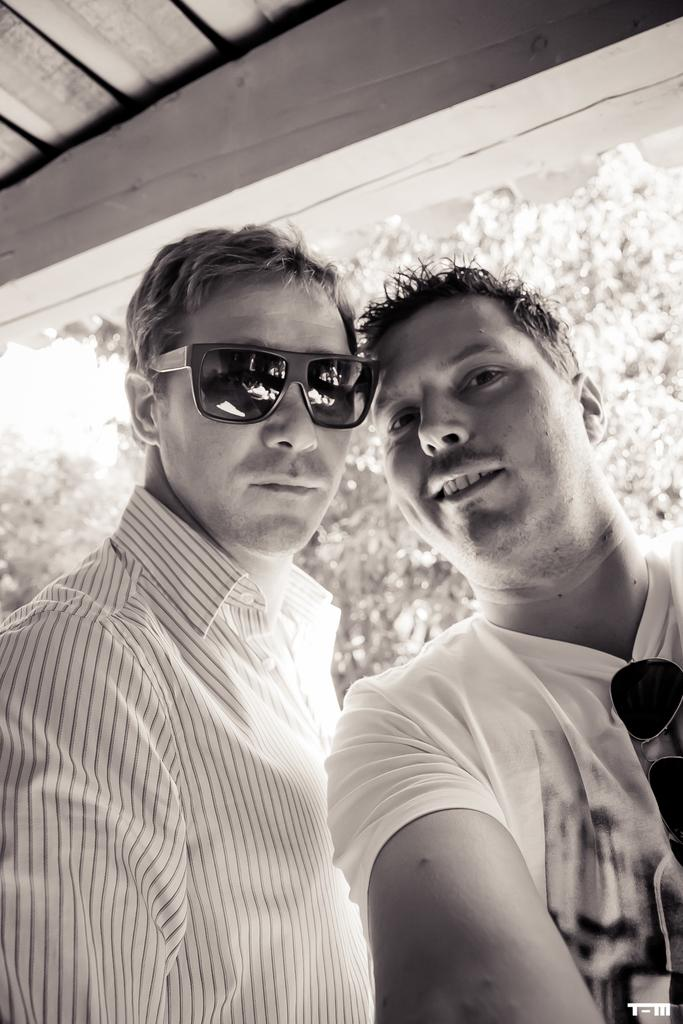How many men are in the front of the image? There are two men in the front and one of them is wearing goggles. Where is the man wearing goggles located in the image? The man wearing goggles is on the left side of the image. What can be seen in the background of the image? There are trees in the background of the image. What is present at the bottom right of the image? There is some text at the bottom right of the image. What type of crime is being committed by the man with the fork in the image? There is no man with a fork present in the image, and therefore no crime can be observed. 